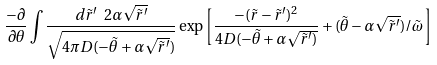<formula> <loc_0><loc_0><loc_500><loc_500>\frac { - \partial } { \partial \theta } \int \frac { d \tilde { r } ^ { \prime } \ 2 \alpha \sqrt { \tilde { r } ^ { \prime } } } { \sqrt { 4 \pi D ( - \tilde { \theta } + \alpha \sqrt { \tilde { r } ^ { \prime } } ) } } \exp \left [ \frac { - ( \tilde { r } - \tilde { r } ^ { \prime } ) ^ { 2 } } { 4 D ( - \tilde { \theta } + \alpha \sqrt { \tilde { r } ^ { \prime } ) } } + ( \tilde { \theta } - \alpha \sqrt { \tilde { r } ^ { \prime } } ) / { \tilde { \omega } } \right ]</formula> 